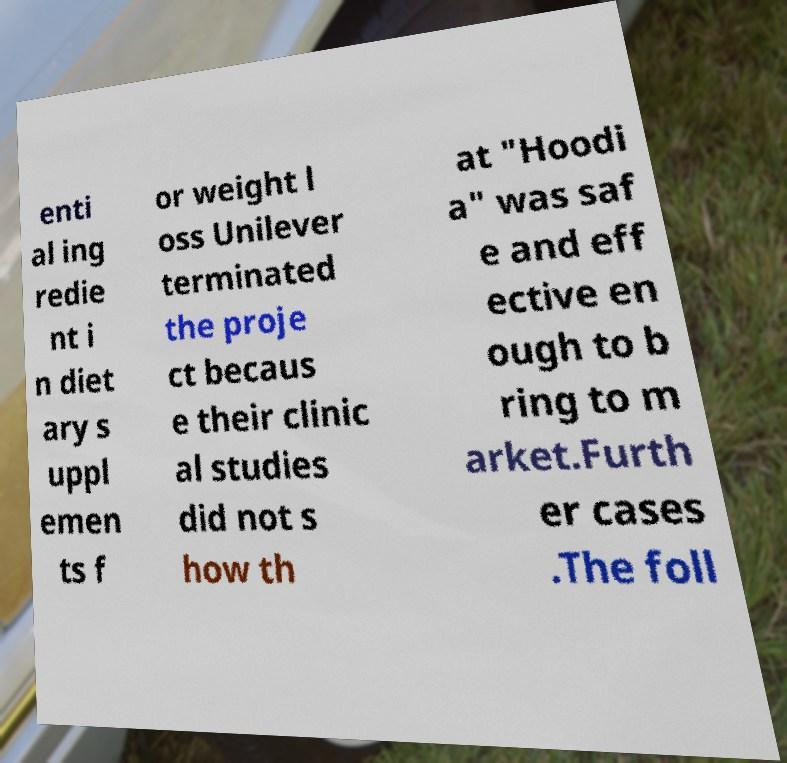What messages or text are displayed in this image? I need them in a readable, typed format. enti al ing redie nt i n diet ary s uppl emen ts f or weight l oss Unilever terminated the proje ct becaus e their clinic al studies did not s how th at "Hoodi a" was saf e and eff ective en ough to b ring to m arket.Furth er cases .The foll 